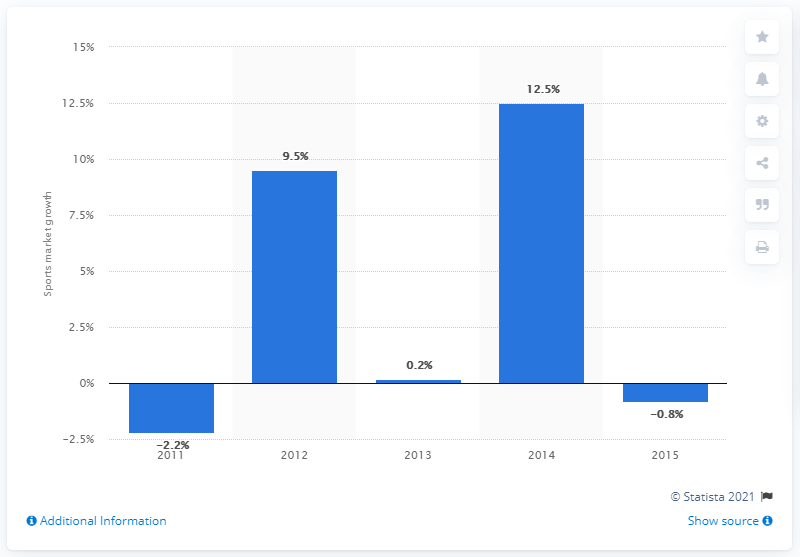Indicate a few pertinent items in this graphic. The global sports market is expected to grow at a projected rate of 0.2% from 2012 to 2013. 